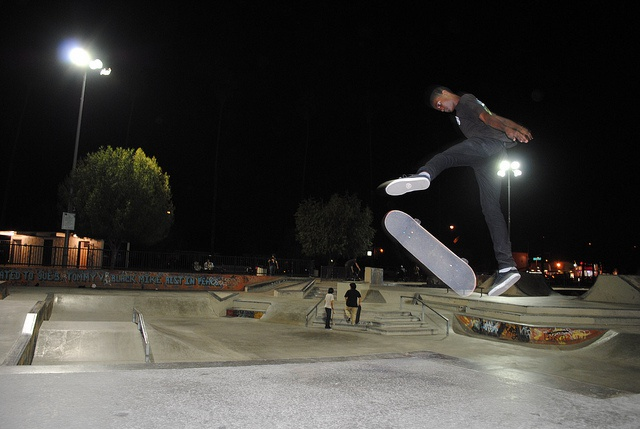Describe the objects in this image and their specific colors. I can see people in black, gray, darkgray, and lightgray tones, skateboard in black, darkgray, gray, and lightgray tones, people in black, olive, and gray tones, people in black, gray, and darkgray tones, and people in black, maroon, and gray tones in this image. 